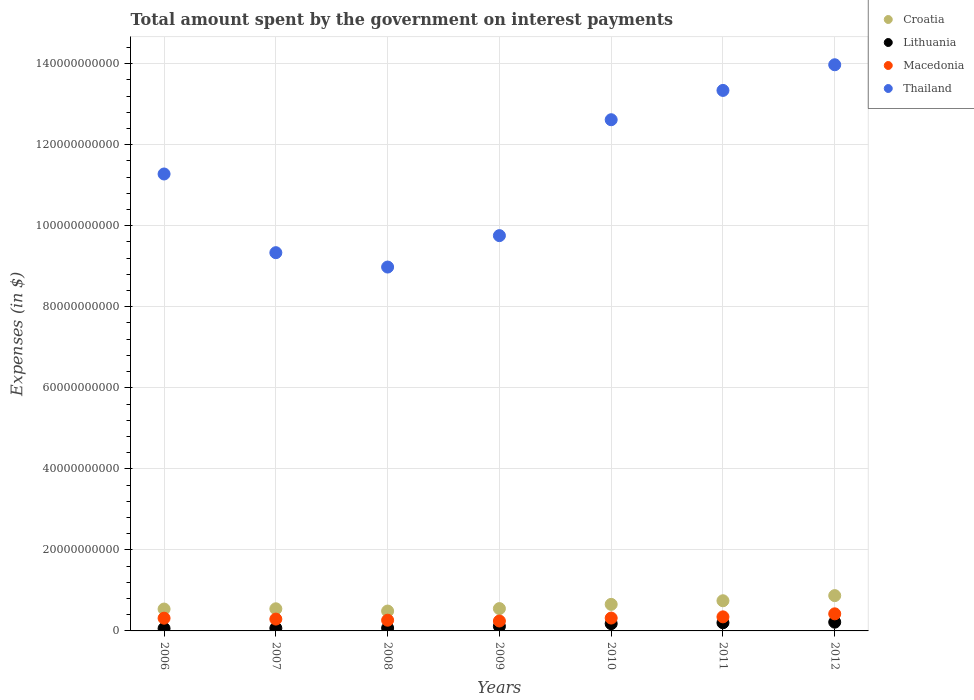How many different coloured dotlines are there?
Ensure brevity in your answer.  4. Is the number of dotlines equal to the number of legend labels?
Keep it short and to the point. Yes. What is the amount spent on interest payments by the government in Macedonia in 2010?
Provide a short and direct response. 3.17e+09. Across all years, what is the maximum amount spent on interest payments by the government in Thailand?
Offer a terse response. 1.40e+11. Across all years, what is the minimum amount spent on interest payments by the government in Macedonia?
Make the answer very short. 2.44e+09. In which year was the amount spent on interest payments by the government in Macedonia maximum?
Your response must be concise. 2012. What is the total amount spent on interest payments by the government in Thailand in the graph?
Make the answer very short. 7.93e+11. What is the difference between the amount spent on interest payments by the government in Croatia in 2007 and that in 2008?
Your response must be concise. 5.60e+08. What is the difference between the amount spent on interest payments by the government in Macedonia in 2012 and the amount spent on interest payments by the government in Lithuania in 2009?
Your response must be concise. 3.09e+09. What is the average amount spent on interest payments by the government in Thailand per year?
Give a very brief answer. 1.13e+11. In the year 2007, what is the difference between the amount spent on interest payments by the government in Croatia and amount spent on interest payments by the government in Thailand?
Provide a short and direct response. -8.79e+1. What is the ratio of the amount spent on interest payments by the government in Croatia in 2007 to that in 2011?
Your response must be concise. 0.73. Is the difference between the amount spent on interest payments by the government in Croatia in 2007 and 2008 greater than the difference between the amount spent on interest payments by the government in Thailand in 2007 and 2008?
Offer a very short reply. No. What is the difference between the highest and the second highest amount spent on interest payments by the government in Lithuania?
Make the answer very short. 1.48e+08. What is the difference between the highest and the lowest amount spent on interest payments by the government in Croatia?
Your response must be concise. 3.81e+09. In how many years, is the amount spent on interest payments by the government in Lithuania greater than the average amount spent on interest payments by the government in Lithuania taken over all years?
Keep it short and to the point. 3. Is the sum of the amount spent on interest payments by the government in Lithuania in 2008 and 2011 greater than the maximum amount spent on interest payments by the government in Macedonia across all years?
Your answer should be compact. No. Does the amount spent on interest payments by the government in Croatia monotonically increase over the years?
Offer a terse response. No. Is the amount spent on interest payments by the government in Macedonia strictly less than the amount spent on interest payments by the government in Lithuania over the years?
Your answer should be compact. No. What is the difference between two consecutive major ticks on the Y-axis?
Your answer should be very brief. 2.00e+1. Does the graph contain any zero values?
Ensure brevity in your answer.  No. Where does the legend appear in the graph?
Make the answer very short. Top right. How many legend labels are there?
Ensure brevity in your answer.  4. How are the legend labels stacked?
Your response must be concise. Vertical. What is the title of the graph?
Ensure brevity in your answer.  Total amount spent by the government on interest payments. What is the label or title of the Y-axis?
Offer a very short reply. Expenses (in $). What is the Expenses (in $) of Croatia in 2006?
Provide a succinct answer. 5.40e+09. What is the Expenses (in $) of Lithuania in 2006?
Offer a terse response. 6.00e+08. What is the Expenses (in $) in Macedonia in 2006?
Offer a very short reply. 3.14e+09. What is the Expenses (in $) in Thailand in 2006?
Make the answer very short. 1.13e+11. What is the Expenses (in $) of Croatia in 2007?
Keep it short and to the point. 5.46e+09. What is the Expenses (in $) of Lithuania in 2007?
Keep it short and to the point. 6.70e+08. What is the Expenses (in $) in Macedonia in 2007?
Your response must be concise. 2.92e+09. What is the Expenses (in $) in Thailand in 2007?
Offer a terse response. 9.33e+1. What is the Expenses (in $) in Croatia in 2008?
Provide a short and direct response. 4.90e+09. What is the Expenses (in $) in Lithuania in 2008?
Make the answer very short. 7.02e+08. What is the Expenses (in $) of Macedonia in 2008?
Provide a succinct answer. 2.65e+09. What is the Expenses (in $) in Thailand in 2008?
Your response must be concise. 8.98e+1. What is the Expenses (in $) in Croatia in 2009?
Offer a terse response. 5.51e+09. What is the Expenses (in $) in Lithuania in 2009?
Provide a succinct answer. 1.13e+09. What is the Expenses (in $) in Macedonia in 2009?
Your answer should be compact. 2.44e+09. What is the Expenses (in $) in Thailand in 2009?
Make the answer very short. 9.76e+1. What is the Expenses (in $) in Croatia in 2010?
Your response must be concise. 6.55e+09. What is the Expenses (in $) in Lithuania in 2010?
Give a very brief answer. 1.79e+09. What is the Expenses (in $) of Macedonia in 2010?
Provide a succinct answer. 3.17e+09. What is the Expenses (in $) in Thailand in 2010?
Your response must be concise. 1.26e+11. What is the Expenses (in $) in Croatia in 2011?
Keep it short and to the point. 7.44e+09. What is the Expenses (in $) of Lithuania in 2011?
Give a very brief answer. 2.01e+09. What is the Expenses (in $) of Macedonia in 2011?
Provide a succinct answer. 3.47e+09. What is the Expenses (in $) in Thailand in 2011?
Give a very brief answer. 1.33e+11. What is the Expenses (in $) in Croatia in 2012?
Provide a succinct answer. 8.71e+09. What is the Expenses (in $) of Lithuania in 2012?
Ensure brevity in your answer.  2.16e+09. What is the Expenses (in $) of Macedonia in 2012?
Offer a terse response. 4.22e+09. What is the Expenses (in $) of Thailand in 2012?
Provide a short and direct response. 1.40e+11. Across all years, what is the maximum Expenses (in $) of Croatia?
Offer a terse response. 8.71e+09. Across all years, what is the maximum Expenses (in $) of Lithuania?
Offer a terse response. 2.16e+09. Across all years, what is the maximum Expenses (in $) of Macedonia?
Offer a terse response. 4.22e+09. Across all years, what is the maximum Expenses (in $) in Thailand?
Ensure brevity in your answer.  1.40e+11. Across all years, what is the minimum Expenses (in $) in Croatia?
Provide a short and direct response. 4.90e+09. Across all years, what is the minimum Expenses (in $) in Lithuania?
Give a very brief answer. 6.00e+08. Across all years, what is the minimum Expenses (in $) of Macedonia?
Ensure brevity in your answer.  2.44e+09. Across all years, what is the minimum Expenses (in $) of Thailand?
Provide a succinct answer. 8.98e+1. What is the total Expenses (in $) in Croatia in the graph?
Your answer should be compact. 4.40e+1. What is the total Expenses (in $) of Lithuania in the graph?
Ensure brevity in your answer.  9.06e+09. What is the total Expenses (in $) of Macedonia in the graph?
Provide a short and direct response. 2.20e+1. What is the total Expenses (in $) of Thailand in the graph?
Your answer should be compact. 7.93e+11. What is the difference between the Expenses (in $) in Croatia in 2006 and that in 2007?
Your response must be concise. -6.40e+07. What is the difference between the Expenses (in $) in Lithuania in 2006 and that in 2007?
Make the answer very short. -7.02e+07. What is the difference between the Expenses (in $) of Macedonia in 2006 and that in 2007?
Provide a short and direct response. 2.22e+08. What is the difference between the Expenses (in $) of Thailand in 2006 and that in 2007?
Give a very brief answer. 1.94e+1. What is the difference between the Expenses (in $) in Croatia in 2006 and that in 2008?
Make the answer very short. 4.96e+08. What is the difference between the Expenses (in $) in Lithuania in 2006 and that in 2008?
Ensure brevity in your answer.  -1.02e+08. What is the difference between the Expenses (in $) in Macedonia in 2006 and that in 2008?
Give a very brief answer. 4.94e+08. What is the difference between the Expenses (in $) in Thailand in 2006 and that in 2008?
Offer a terse response. 2.30e+1. What is the difference between the Expenses (in $) in Croatia in 2006 and that in 2009?
Your response must be concise. -1.13e+08. What is the difference between the Expenses (in $) in Lithuania in 2006 and that in 2009?
Your response must be concise. -5.28e+08. What is the difference between the Expenses (in $) of Macedonia in 2006 and that in 2009?
Give a very brief answer. 6.95e+08. What is the difference between the Expenses (in $) in Thailand in 2006 and that in 2009?
Offer a very short reply. 1.52e+1. What is the difference between the Expenses (in $) in Croatia in 2006 and that in 2010?
Keep it short and to the point. -1.15e+09. What is the difference between the Expenses (in $) of Lithuania in 2006 and that in 2010?
Provide a short and direct response. -1.19e+09. What is the difference between the Expenses (in $) of Macedonia in 2006 and that in 2010?
Offer a very short reply. -3.39e+07. What is the difference between the Expenses (in $) of Thailand in 2006 and that in 2010?
Your response must be concise. -1.34e+1. What is the difference between the Expenses (in $) of Croatia in 2006 and that in 2011?
Offer a very short reply. -2.05e+09. What is the difference between the Expenses (in $) in Lithuania in 2006 and that in 2011?
Ensure brevity in your answer.  -1.41e+09. What is the difference between the Expenses (in $) in Macedonia in 2006 and that in 2011?
Provide a succinct answer. -3.31e+08. What is the difference between the Expenses (in $) of Thailand in 2006 and that in 2011?
Ensure brevity in your answer.  -2.06e+1. What is the difference between the Expenses (in $) in Croatia in 2006 and that in 2012?
Keep it short and to the point. -3.32e+09. What is the difference between the Expenses (in $) in Lithuania in 2006 and that in 2012?
Offer a terse response. -1.56e+09. What is the difference between the Expenses (in $) in Macedonia in 2006 and that in 2012?
Provide a succinct answer. -1.08e+09. What is the difference between the Expenses (in $) in Thailand in 2006 and that in 2012?
Provide a succinct answer. -2.70e+1. What is the difference between the Expenses (in $) in Croatia in 2007 and that in 2008?
Your response must be concise. 5.60e+08. What is the difference between the Expenses (in $) in Lithuania in 2007 and that in 2008?
Offer a terse response. -3.16e+07. What is the difference between the Expenses (in $) in Macedonia in 2007 and that in 2008?
Provide a succinct answer. 2.72e+08. What is the difference between the Expenses (in $) of Thailand in 2007 and that in 2008?
Offer a very short reply. 3.55e+09. What is the difference between the Expenses (in $) in Croatia in 2007 and that in 2009?
Provide a short and direct response. -4.88e+07. What is the difference between the Expenses (in $) in Lithuania in 2007 and that in 2009?
Provide a succinct answer. -4.57e+08. What is the difference between the Expenses (in $) of Macedonia in 2007 and that in 2009?
Your response must be concise. 4.73e+08. What is the difference between the Expenses (in $) in Thailand in 2007 and that in 2009?
Make the answer very short. -4.21e+09. What is the difference between the Expenses (in $) in Croatia in 2007 and that in 2010?
Keep it short and to the point. -1.09e+09. What is the difference between the Expenses (in $) of Lithuania in 2007 and that in 2010?
Provide a succinct answer. -1.12e+09. What is the difference between the Expenses (in $) of Macedonia in 2007 and that in 2010?
Provide a short and direct response. -2.56e+08. What is the difference between the Expenses (in $) in Thailand in 2007 and that in 2010?
Your answer should be very brief. -3.28e+1. What is the difference between the Expenses (in $) in Croatia in 2007 and that in 2011?
Give a very brief answer. -1.98e+09. What is the difference between the Expenses (in $) of Lithuania in 2007 and that in 2011?
Give a very brief answer. -1.34e+09. What is the difference between the Expenses (in $) of Macedonia in 2007 and that in 2011?
Keep it short and to the point. -5.53e+08. What is the difference between the Expenses (in $) of Thailand in 2007 and that in 2011?
Offer a terse response. -4.00e+1. What is the difference between the Expenses (in $) of Croatia in 2007 and that in 2012?
Give a very brief answer. -3.25e+09. What is the difference between the Expenses (in $) of Lithuania in 2007 and that in 2012?
Offer a terse response. -1.49e+09. What is the difference between the Expenses (in $) in Macedonia in 2007 and that in 2012?
Make the answer very short. -1.30e+09. What is the difference between the Expenses (in $) of Thailand in 2007 and that in 2012?
Your response must be concise. -4.64e+1. What is the difference between the Expenses (in $) in Croatia in 2008 and that in 2009?
Give a very brief answer. -6.09e+08. What is the difference between the Expenses (in $) of Lithuania in 2008 and that in 2009?
Ensure brevity in your answer.  -4.26e+08. What is the difference between the Expenses (in $) in Macedonia in 2008 and that in 2009?
Provide a short and direct response. 2.01e+08. What is the difference between the Expenses (in $) in Thailand in 2008 and that in 2009?
Your response must be concise. -7.75e+09. What is the difference between the Expenses (in $) of Croatia in 2008 and that in 2010?
Keep it short and to the point. -1.65e+09. What is the difference between the Expenses (in $) in Lithuania in 2008 and that in 2010?
Ensure brevity in your answer.  -1.09e+09. What is the difference between the Expenses (in $) in Macedonia in 2008 and that in 2010?
Your answer should be compact. -5.28e+08. What is the difference between the Expenses (in $) in Thailand in 2008 and that in 2010?
Provide a succinct answer. -3.64e+1. What is the difference between the Expenses (in $) in Croatia in 2008 and that in 2011?
Offer a very short reply. -2.54e+09. What is the difference between the Expenses (in $) in Lithuania in 2008 and that in 2011?
Provide a short and direct response. -1.31e+09. What is the difference between the Expenses (in $) in Macedonia in 2008 and that in 2011?
Make the answer very short. -8.25e+08. What is the difference between the Expenses (in $) of Thailand in 2008 and that in 2011?
Your response must be concise. -4.36e+1. What is the difference between the Expenses (in $) in Croatia in 2008 and that in 2012?
Keep it short and to the point. -3.81e+09. What is the difference between the Expenses (in $) of Lithuania in 2008 and that in 2012?
Offer a terse response. -1.46e+09. What is the difference between the Expenses (in $) of Macedonia in 2008 and that in 2012?
Provide a succinct answer. -1.57e+09. What is the difference between the Expenses (in $) of Thailand in 2008 and that in 2012?
Provide a short and direct response. -4.99e+1. What is the difference between the Expenses (in $) of Croatia in 2009 and that in 2010?
Provide a succinct answer. -1.04e+09. What is the difference between the Expenses (in $) in Lithuania in 2009 and that in 2010?
Offer a very short reply. -6.61e+08. What is the difference between the Expenses (in $) of Macedonia in 2009 and that in 2010?
Give a very brief answer. -7.29e+08. What is the difference between the Expenses (in $) of Thailand in 2009 and that in 2010?
Make the answer very short. -2.86e+1. What is the difference between the Expenses (in $) in Croatia in 2009 and that in 2011?
Make the answer very short. -1.93e+09. What is the difference between the Expenses (in $) in Lithuania in 2009 and that in 2011?
Provide a succinct answer. -8.82e+08. What is the difference between the Expenses (in $) of Macedonia in 2009 and that in 2011?
Give a very brief answer. -1.03e+09. What is the difference between the Expenses (in $) in Thailand in 2009 and that in 2011?
Give a very brief answer. -3.58e+1. What is the difference between the Expenses (in $) in Croatia in 2009 and that in 2012?
Your response must be concise. -3.20e+09. What is the difference between the Expenses (in $) in Lithuania in 2009 and that in 2012?
Your answer should be compact. -1.03e+09. What is the difference between the Expenses (in $) in Macedonia in 2009 and that in 2012?
Offer a very short reply. -1.77e+09. What is the difference between the Expenses (in $) of Thailand in 2009 and that in 2012?
Your response must be concise. -4.22e+1. What is the difference between the Expenses (in $) in Croatia in 2010 and that in 2011?
Provide a succinct answer. -8.93e+08. What is the difference between the Expenses (in $) in Lithuania in 2010 and that in 2011?
Your answer should be very brief. -2.20e+08. What is the difference between the Expenses (in $) in Macedonia in 2010 and that in 2011?
Ensure brevity in your answer.  -2.97e+08. What is the difference between the Expenses (in $) in Thailand in 2010 and that in 2011?
Provide a succinct answer. -7.23e+09. What is the difference between the Expenses (in $) in Croatia in 2010 and that in 2012?
Your response must be concise. -2.16e+09. What is the difference between the Expenses (in $) in Lithuania in 2010 and that in 2012?
Offer a terse response. -3.69e+08. What is the difference between the Expenses (in $) of Macedonia in 2010 and that in 2012?
Offer a terse response. -1.04e+09. What is the difference between the Expenses (in $) of Thailand in 2010 and that in 2012?
Your response must be concise. -1.36e+1. What is the difference between the Expenses (in $) of Croatia in 2011 and that in 2012?
Provide a short and direct response. -1.27e+09. What is the difference between the Expenses (in $) of Lithuania in 2011 and that in 2012?
Give a very brief answer. -1.48e+08. What is the difference between the Expenses (in $) in Macedonia in 2011 and that in 2012?
Ensure brevity in your answer.  -7.45e+08. What is the difference between the Expenses (in $) in Thailand in 2011 and that in 2012?
Offer a terse response. -6.33e+09. What is the difference between the Expenses (in $) in Croatia in 2006 and the Expenses (in $) in Lithuania in 2007?
Your response must be concise. 4.73e+09. What is the difference between the Expenses (in $) in Croatia in 2006 and the Expenses (in $) in Macedonia in 2007?
Provide a succinct answer. 2.48e+09. What is the difference between the Expenses (in $) of Croatia in 2006 and the Expenses (in $) of Thailand in 2007?
Offer a very short reply. -8.80e+1. What is the difference between the Expenses (in $) in Lithuania in 2006 and the Expenses (in $) in Macedonia in 2007?
Provide a short and direct response. -2.32e+09. What is the difference between the Expenses (in $) of Lithuania in 2006 and the Expenses (in $) of Thailand in 2007?
Ensure brevity in your answer.  -9.27e+1. What is the difference between the Expenses (in $) of Macedonia in 2006 and the Expenses (in $) of Thailand in 2007?
Your answer should be compact. -9.02e+1. What is the difference between the Expenses (in $) of Croatia in 2006 and the Expenses (in $) of Lithuania in 2008?
Your response must be concise. 4.69e+09. What is the difference between the Expenses (in $) of Croatia in 2006 and the Expenses (in $) of Macedonia in 2008?
Your answer should be very brief. 2.75e+09. What is the difference between the Expenses (in $) in Croatia in 2006 and the Expenses (in $) in Thailand in 2008?
Provide a succinct answer. -8.44e+1. What is the difference between the Expenses (in $) of Lithuania in 2006 and the Expenses (in $) of Macedonia in 2008?
Offer a terse response. -2.05e+09. What is the difference between the Expenses (in $) in Lithuania in 2006 and the Expenses (in $) in Thailand in 2008?
Make the answer very short. -8.92e+1. What is the difference between the Expenses (in $) of Macedonia in 2006 and the Expenses (in $) of Thailand in 2008?
Provide a short and direct response. -8.67e+1. What is the difference between the Expenses (in $) of Croatia in 2006 and the Expenses (in $) of Lithuania in 2009?
Give a very brief answer. 4.27e+09. What is the difference between the Expenses (in $) of Croatia in 2006 and the Expenses (in $) of Macedonia in 2009?
Provide a succinct answer. 2.95e+09. What is the difference between the Expenses (in $) in Croatia in 2006 and the Expenses (in $) in Thailand in 2009?
Provide a short and direct response. -9.22e+1. What is the difference between the Expenses (in $) in Lithuania in 2006 and the Expenses (in $) in Macedonia in 2009?
Give a very brief answer. -1.84e+09. What is the difference between the Expenses (in $) in Lithuania in 2006 and the Expenses (in $) in Thailand in 2009?
Provide a succinct answer. -9.70e+1. What is the difference between the Expenses (in $) of Macedonia in 2006 and the Expenses (in $) of Thailand in 2009?
Offer a terse response. -9.44e+1. What is the difference between the Expenses (in $) in Croatia in 2006 and the Expenses (in $) in Lithuania in 2010?
Your response must be concise. 3.61e+09. What is the difference between the Expenses (in $) of Croatia in 2006 and the Expenses (in $) of Macedonia in 2010?
Your response must be concise. 2.22e+09. What is the difference between the Expenses (in $) in Croatia in 2006 and the Expenses (in $) in Thailand in 2010?
Provide a short and direct response. -1.21e+11. What is the difference between the Expenses (in $) in Lithuania in 2006 and the Expenses (in $) in Macedonia in 2010?
Offer a very short reply. -2.57e+09. What is the difference between the Expenses (in $) of Lithuania in 2006 and the Expenses (in $) of Thailand in 2010?
Offer a terse response. -1.26e+11. What is the difference between the Expenses (in $) of Macedonia in 2006 and the Expenses (in $) of Thailand in 2010?
Your answer should be compact. -1.23e+11. What is the difference between the Expenses (in $) in Croatia in 2006 and the Expenses (in $) in Lithuania in 2011?
Provide a short and direct response. 3.39e+09. What is the difference between the Expenses (in $) in Croatia in 2006 and the Expenses (in $) in Macedonia in 2011?
Provide a succinct answer. 1.93e+09. What is the difference between the Expenses (in $) of Croatia in 2006 and the Expenses (in $) of Thailand in 2011?
Offer a very short reply. -1.28e+11. What is the difference between the Expenses (in $) in Lithuania in 2006 and the Expenses (in $) in Macedonia in 2011?
Your response must be concise. -2.87e+09. What is the difference between the Expenses (in $) of Lithuania in 2006 and the Expenses (in $) of Thailand in 2011?
Provide a short and direct response. -1.33e+11. What is the difference between the Expenses (in $) in Macedonia in 2006 and the Expenses (in $) in Thailand in 2011?
Ensure brevity in your answer.  -1.30e+11. What is the difference between the Expenses (in $) of Croatia in 2006 and the Expenses (in $) of Lithuania in 2012?
Make the answer very short. 3.24e+09. What is the difference between the Expenses (in $) in Croatia in 2006 and the Expenses (in $) in Macedonia in 2012?
Your answer should be very brief. 1.18e+09. What is the difference between the Expenses (in $) in Croatia in 2006 and the Expenses (in $) in Thailand in 2012?
Make the answer very short. -1.34e+11. What is the difference between the Expenses (in $) in Lithuania in 2006 and the Expenses (in $) in Macedonia in 2012?
Offer a very short reply. -3.62e+09. What is the difference between the Expenses (in $) in Lithuania in 2006 and the Expenses (in $) in Thailand in 2012?
Your answer should be very brief. -1.39e+11. What is the difference between the Expenses (in $) in Macedonia in 2006 and the Expenses (in $) in Thailand in 2012?
Offer a terse response. -1.37e+11. What is the difference between the Expenses (in $) of Croatia in 2007 and the Expenses (in $) of Lithuania in 2008?
Your answer should be very brief. 4.76e+09. What is the difference between the Expenses (in $) of Croatia in 2007 and the Expenses (in $) of Macedonia in 2008?
Your response must be concise. 2.82e+09. What is the difference between the Expenses (in $) in Croatia in 2007 and the Expenses (in $) in Thailand in 2008?
Your answer should be compact. -8.43e+1. What is the difference between the Expenses (in $) of Lithuania in 2007 and the Expenses (in $) of Macedonia in 2008?
Your answer should be compact. -1.98e+09. What is the difference between the Expenses (in $) in Lithuania in 2007 and the Expenses (in $) in Thailand in 2008?
Your answer should be very brief. -8.91e+1. What is the difference between the Expenses (in $) of Macedonia in 2007 and the Expenses (in $) of Thailand in 2008?
Give a very brief answer. -8.69e+1. What is the difference between the Expenses (in $) in Croatia in 2007 and the Expenses (in $) in Lithuania in 2009?
Keep it short and to the point. 4.33e+09. What is the difference between the Expenses (in $) of Croatia in 2007 and the Expenses (in $) of Macedonia in 2009?
Keep it short and to the point. 3.02e+09. What is the difference between the Expenses (in $) in Croatia in 2007 and the Expenses (in $) in Thailand in 2009?
Your answer should be very brief. -9.21e+1. What is the difference between the Expenses (in $) in Lithuania in 2007 and the Expenses (in $) in Macedonia in 2009?
Keep it short and to the point. -1.77e+09. What is the difference between the Expenses (in $) of Lithuania in 2007 and the Expenses (in $) of Thailand in 2009?
Provide a succinct answer. -9.69e+1. What is the difference between the Expenses (in $) of Macedonia in 2007 and the Expenses (in $) of Thailand in 2009?
Keep it short and to the point. -9.46e+1. What is the difference between the Expenses (in $) of Croatia in 2007 and the Expenses (in $) of Lithuania in 2010?
Keep it short and to the point. 3.67e+09. What is the difference between the Expenses (in $) in Croatia in 2007 and the Expenses (in $) in Macedonia in 2010?
Your response must be concise. 2.29e+09. What is the difference between the Expenses (in $) of Croatia in 2007 and the Expenses (in $) of Thailand in 2010?
Provide a short and direct response. -1.21e+11. What is the difference between the Expenses (in $) in Lithuania in 2007 and the Expenses (in $) in Macedonia in 2010?
Offer a terse response. -2.50e+09. What is the difference between the Expenses (in $) of Lithuania in 2007 and the Expenses (in $) of Thailand in 2010?
Ensure brevity in your answer.  -1.25e+11. What is the difference between the Expenses (in $) in Macedonia in 2007 and the Expenses (in $) in Thailand in 2010?
Your response must be concise. -1.23e+11. What is the difference between the Expenses (in $) in Croatia in 2007 and the Expenses (in $) in Lithuania in 2011?
Keep it short and to the point. 3.45e+09. What is the difference between the Expenses (in $) of Croatia in 2007 and the Expenses (in $) of Macedonia in 2011?
Your answer should be very brief. 1.99e+09. What is the difference between the Expenses (in $) in Croatia in 2007 and the Expenses (in $) in Thailand in 2011?
Provide a succinct answer. -1.28e+11. What is the difference between the Expenses (in $) in Lithuania in 2007 and the Expenses (in $) in Macedonia in 2011?
Your response must be concise. -2.80e+09. What is the difference between the Expenses (in $) in Lithuania in 2007 and the Expenses (in $) in Thailand in 2011?
Keep it short and to the point. -1.33e+11. What is the difference between the Expenses (in $) of Macedonia in 2007 and the Expenses (in $) of Thailand in 2011?
Your answer should be very brief. -1.30e+11. What is the difference between the Expenses (in $) of Croatia in 2007 and the Expenses (in $) of Lithuania in 2012?
Make the answer very short. 3.30e+09. What is the difference between the Expenses (in $) in Croatia in 2007 and the Expenses (in $) in Macedonia in 2012?
Offer a very short reply. 1.24e+09. What is the difference between the Expenses (in $) of Croatia in 2007 and the Expenses (in $) of Thailand in 2012?
Ensure brevity in your answer.  -1.34e+11. What is the difference between the Expenses (in $) in Lithuania in 2007 and the Expenses (in $) in Macedonia in 2012?
Your response must be concise. -3.55e+09. What is the difference between the Expenses (in $) in Lithuania in 2007 and the Expenses (in $) in Thailand in 2012?
Make the answer very short. -1.39e+11. What is the difference between the Expenses (in $) in Macedonia in 2007 and the Expenses (in $) in Thailand in 2012?
Your response must be concise. -1.37e+11. What is the difference between the Expenses (in $) in Croatia in 2008 and the Expenses (in $) in Lithuania in 2009?
Your answer should be very brief. 3.77e+09. What is the difference between the Expenses (in $) in Croatia in 2008 and the Expenses (in $) in Macedonia in 2009?
Ensure brevity in your answer.  2.46e+09. What is the difference between the Expenses (in $) of Croatia in 2008 and the Expenses (in $) of Thailand in 2009?
Provide a short and direct response. -9.27e+1. What is the difference between the Expenses (in $) of Lithuania in 2008 and the Expenses (in $) of Macedonia in 2009?
Provide a short and direct response. -1.74e+09. What is the difference between the Expenses (in $) in Lithuania in 2008 and the Expenses (in $) in Thailand in 2009?
Ensure brevity in your answer.  -9.69e+1. What is the difference between the Expenses (in $) of Macedonia in 2008 and the Expenses (in $) of Thailand in 2009?
Offer a very short reply. -9.49e+1. What is the difference between the Expenses (in $) of Croatia in 2008 and the Expenses (in $) of Lithuania in 2010?
Provide a short and direct response. 3.11e+09. What is the difference between the Expenses (in $) in Croatia in 2008 and the Expenses (in $) in Macedonia in 2010?
Your answer should be very brief. 1.73e+09. What is the difference between the Expenses (in $) of Croatia in 2008 and the Expenses (in $) of Thailand in 2010?
Give a very brief answer. -1.21e+11. What is the difference between the Expenses (in $) in Lithuania in 2008 and the Expenses (in $) in Macedonia in 2010?
Give a very brief answer. -2.47e+09. What is the difference between the Expenses (in $) of Lithuania in 2008 and the Expenses (in $) of Thailand in 2010?
Give a very brief answer. -1.25e+11. What is the difference between the Expenses (in $) of Macedonia in 2008 and the Expenses (in $) of Thailand in 2010?
Offer a very short reply. -1.24e+11. What is the difference between the Expenses (in $) of Croatia in 2008 and the Expenses (in $) of Lithuania in 2011?
Provide a short and direct response. 2.89e+09. What is the difference between the Expenses (in $) of Croatia in 2008 and the Expenses (in $) of Macedonia in 2011?
Your answer should be very brief. 1.43e+09. What is the difference between the Expenses (in $) in Croatia in 2008 and the Expenses (in $) in Thailand in 2011?
Offer a very short reply. -1.28e+11. What is the difference between the Expenses (in $) in Lithuania in 2008 and the Expenses (in $) in Macedonia in 2011?
Provide a succinct answer. -2.77e+09. What is the difference between the Expenses (in $) of Lithuania in 2008 and the Expenses (in $) of Thailand in 2011?
Provide a short and direct response. -1.33e+11. What is the difference between the Expenses (in $) in Macedonia in 2008 and the Expenses (in $) in Thailand in 2011?
Offer a very short reply. -1.31e+11. What is the difference between the Expenses (in $) of Croatia in 2008 and the Expenses (in $) of Lithuania in 2012?
Your answer should be very brief. 2.74e+09. What is the difference between the Expenses (in $) of Croatia in 2008 and the Expenses (in $) of Macedonia in 2012?
Give a very brief answer. 6.85e+08. What is the difference between the Expenses (in $) in Croatia in 2008 and the Expenses (in $) in Thailand in 2012?
Give a very brief answer. -1.35e+11. What is the difference between the Expenses (in $) in Lithuania in 2008 and the Expenses (in $) in Macedonia in 2012?
Make the answer very short. -3.51e+09. What is the difference between the Expenses (in $) of Lithuania in 2008 and the Expenses (in $) of Thailand in 2012?
Provide a short and direct response. -1.39e+11. What is the difference between the Expenses (in $) in Macedonia in 2008 and the Expenses (in $) in Thailand in 2012?
Provide a succinct answer. -1.37e+11. What is the difference between the Expenses (in $) of Croatia in 2009 and the Expenses (in $) of Lithuania in 2010?
Your response must be concise. 3.72e+09. What is the difference between the Expenses (in $) of Croatia in 2009 and the Expenses (in $) of Macedonia in 2010?
Ensure brevity in your answer.  2.34e+09. What is the difference between the Expenses (in $) in Croatia in 2009 and the Expenses (in $) in Thailand in 2010?
Provide a short and direct response. -1.21e+11. What is the difference between the Expenses (in $) of Lithuania in 2009 and the Expenses (in $) of Macedonia in 2010?
Provide a short and direct response. -2.05e+09. What is the difference between the Expenses (in $) in Lithuania in 2009 and the Expenses (in $) in Thailand in 2010?
Provide a succinct answer. -1.25e+11. What is the difference between the Expenses (in $) in Macedonia in 2009 and the Expenses (in $) in Thailand in 2010?
Your answer should be very brief. -1.24e+11. What is the difference between the Expenses (in $) in Croatia in 2009 and the Expenses (in $) in Lithuania in 2011?
Provide a succinct answer. 3.50e+09. What is the difference between the Expenses (in $) in Croatia in 2009 and the Expenses (in $) in Macedonia in 2011?
Give a very brief answer. 2.04e+09. What is the difference between the Expenses (in $) in Croatia in 2009 and the Expenses (in $) in Thailand in 2011?
Provide a short and direct response. -1.28e+11. What is the difference between the Expenses (in $) in Lithuania in 2009 and the Expenses (in $) in Macedonia in 2011?
Ensure brevity in your answer.  -2.34e+09. What is the difference between the Expenses (in $) of Lithuania in 2009 and the Expenses (in $) of Thailand in 2011?
Ensure brevity in your answer.  -1.32e+11. What is the difference between the Expenses (in $) of Macedonia in 2009 and the Expenses (in $) of Thailand in 2011?
Offer a terse response. -1.31e+11. What is the difference between the Expenses (in $) in Croatia in 2009 and the Expenses (in $) in Lithuania in 2012?
Your response must be concise. 3.35e+09. What is the difference between the Expenses (in $) of Croatia in 2009 and the Expenses (in $) of Macedonia in 2012?
Offer a terse response. 1.29e+09. What is the difference between the Expenses (in $) in Croatia in 2009 and the Expenses (in $) in Thailand in 2012?
Offer a terse response. -1.34e+11. What is the difference between the Expenses (in $) of Lithuania in 2009 and the Expenses (in $) of Macedonia in 2012?
Your response must be concise. -3.09e+09. What is the difference between the Expenses (in $) of Lithuania in 2009 and the Expenses (in $) of Thailand in 2012?
Ensure brevity in your answer.  -1.39e+11. What is the difference between the Expenses (in $) of Macedonia in 2009 and the Expenses (in $) of Thailand in 2012?
Provide a succinct answer. -1.37e+11. What is the difference between the Expenses (in $) in Croatia in 2010 and the Expenses (in $) in Lithuania in 2011?
Provide a succinct answer. 4.54e+09. What is the difference between the Expenses (in $) of Croatia in 2010 and the Expenses (in $) of Macedonia in 2011?
Provide a short and direct response. 3.08e+09. What is the difference between the Expenses (in $) in Croatia in 2010 and the Expenses (in $) in Thailand in 2011?
Offer a terse response. -1.27e+11. What is the difference between the Expenses (in $) in Lithuania in 2010 and the Expenses (in $) in Macedonia in 2011?
Provide a succinct answer. -1.68e+09. What is the difference between the Expenses (in $) in Lithuania in 2010 and the Expenses (in $) in Thailand in 2011?
Your response must be concise. -1.32e+11. What is the difference between the Expenses (in $) of Macedonia in 2010 and the Expenses (in $) of Thailand in 2011?
Provide a succinct answer. -1.30e+11. What is the difference between the Expenses (in $) in Croatia in 2010 and the Expenses (in $) in Lithuania in 2012?
Your answer should be very brief. 4.39e+09. What is the difference between the Expenses (in $) of Croatia in 2010 and the Expenses (in $) of Macedonia in 2012?
Provide a short and direct response. 2.34e+09. What is the difference between the Expenses (in $) in Croatia in 2010 and the Expenses (in $) in Thailand in 2012?
Your response must be concise. -1.33e+11. What is the difference between the Expenses (in $) of Lithuania in 2010 and the Expenses (in $) of Macedonia in 2012?
Offer a very short reply. -2.43e+09. What is the difference between the Expenses (in $) in Lithuania in 2010 and the Expenses (in $) in Thailand in 2012?
Keep it short and to the point. -1.38e+11. What is the difference between the Expenses (in $) in Macedonia in 2010 and the Expenses (in $) in Thailand in 2012?
Give a very brief answer. -1.37e+11. What is the difference between the Expenses (in $) of Croatia in 2011 and the Expenses (in $) of Lithuania in 2012?
Keep it short and to the point. 5.29e+09. What is the difference between the Expenses (in $) in Croatia in 2011 and the Expenses (in $) in Macedonia in 2012?
Keep it short and to the point. 3.23e+09. What is the difference between the Expenses (in $) of Croatia in 2011 and the Expenses (in $) of Thailand in 2012?
Offer a very short reply. -1.32e+11. What is the difference between the Expenses (in $) of Lithuania in 2011 and the Expenses (in $) of Macedonia in 2012?
Ensure brevity in your answer.  -2.21e+09. What is the difference between the Expenses (in $) in Lithuania in 2011 and the Expenses (in $) in Thailand in 2012?
Make the answer very short. -1.38e+11. What is the difference between the Expenses (in $) in Macedonia in 2011 and the Expenses (in $) in Thailand in 2012?
Your response must be concise. -1.36e+11. What is the average Expenses (in $) of Croatia per year?
Provide a short and direct response. 6.28e+09. What is the average Expenses (in $) of Lithuania per year?
Your answer should be compact. 1.29e+09. What is the average Expenses (in $) in Macedonia per year?
Give a very brief answer. 3.14e+09. What is the average Expenses (in $) in Thailand per year?
Ensure brevity in your answer.  1.13e+11. In the year 2006, what is the difference between the Expenses (in $) of Croatia and Expenses (in $) of Lithuania?
Keep it short and to the point. 4.80e+09. In the year 2006, what is the difference between the Expenses (in $) of Croatia and Expenses (in $) of Macedonia?
Offer a terse response. 2.26e+09. In the year 2006, what is the difference between the Expenses (in $) of Croatia and Expenses (in $) of Thailand?
Ensure brevity in your answer.  -1.07e+11. In the year 2006, what is the difference between the Expenses (in $) in Lithuania and Expenses (in $) in Macedonia?
Provide a succinct answer. -2.54e+09. In the year 2006, what is the difference between the Expenses (in $) in Lithuania and Expenses (in $) in Thailand?
Offer a terse response. -1.12e+11. In the year 2006, what is the difference between the Expenses (in $) of Macedonia and Expenses (in $) of Thailand?
Make the answer very short. -1.10e+11. In the year 2007, what is the difference between the Expenses (in $) in Croatia and Expenses (in $) in Lithuania?
Provide a short and direct response. 4.79e+09. In the year 2007, what is the difference between the Expenses (in $) of Croatia and Expenses (in $) of Macedonia?
Offer a very short reply. 2.54e+09. In the year 2007, what is the difference between the Expenses (in $) of Croatia and Expenses (in $) of Thailand?
Make the answer very short. -8.79e+1. In the year 2007, what is the difference between the Expenses (in $) in Lithuania and Expenses (in $) in Macedonia?
Give a very brief answer. -2.25e+09. In the year 2007, what is the difference between the Expenses (in $) in Lithuania and Expenses (in $) in Thailand?
Your answer should be compact. -9.27e+1. In the year 2007, what is the difference between the Expenses (in $) of Macedonia and Expenses (in $) of Thailand?
Make the answer very short. -9.04e+1. In the year 2008, what is the difference between the Expenses (in $) of Croatia and Expenses (in $) of Lithuania?
Offer a very short reply. 4.20e+09. In the year 2008, what is the difference between the Expenses (in $) of Croatia and Expenses (in $) of Macedonia?
Provide a succinct answer. 2.26e+09. In the year 2008, what is the difference between the Expenses (in $) in Croatia and Expenses (in $) in Thailand?
Provide a short and direct response. -8.49e+1. In the year 2008, what is the difference between the Expenses (in $) in Lithuania and Expenses (in $) in Macedonia?
Make the answer very short. -1.94e+09. In the year 2008, what is the difference between the Expenses (in $) of Lithuania and Expenses (in $) of Thailand?
Provide a short and direct response. -8.91e+1. In the year 2008, what is the difference between the Expenses (in $) in Macedonia and Expenses (in $) in Thailand?
Keep it short and to the point. -8.72e+1. In the year 2009, what is the difference between the Expenses (in $) in Croatia and Expenses (in $) in Lithuania?
Provide a short and direct response. 4.38e+09. In the year 2009, what is the difference between the Expenses (in $) of Croatia and Expenses (in $) of Macedonia?
Offer a very short reply. 3.06e+09. In the year 2009, what is the difference between the Expenses (in $) in Croatia and Expenses (in $) in Thailand?
Keep it short and to the point. -9.20e+1. In the year 2009, what is the difference between the Expenses (in $) in Lithuania and Expenses (in $) in Macedonia?
Ensure brevity in your answer.  -1.32e+09. In the year 2009, what is the difference between the Expenses (in $) in Lithuania and Expenses (in $) in Thailand?
Offer a very short reply. -9.64e+1. In the year 2009, what is the difference between the Expenses (in $) of Macedonia and Expenses (in $) of Thailand?
Keep it short and to the point. -9.51e+1. In the year 2010, what is the difference between the Expenses (in $) of Croatia and Expenses (in $) of Lithuania?
Give a very brief answer. 4.76e+09. In the year 2010, what is the difference between the Expenses (in $) in Croatia and Expenses (in $) in Macedonia?
Ensure brevity in your answer.  3.38e+09. In the year 2010, what is the difference between the Expenses (in $) of Croatia and Expenses (in $) of Thailand?
Give a very brief answer. -1.20e+11. In the year 2010, what is the difference between the Expenses (in $) in Lithuania and Expenses (in $) in Macedonia?
Make the answer very short. -1.38e+09. In the year 2010, what is the difference between the Expenses (in $) of Lithuania and Expenses (in $) of Thailand?
Your response must be concise. -1.24e+11. In the year 2010, what is the difference between the Expenses (in $) in Macedonia and Expenses (in $) in Thailand?
Offer a very short reply. -1.23e+11. In the year 2011, what is the difference between the Expenses (in $) of Croatia and Expenses (in $) of Lithuania?
Give a very brief answer. 5.44e+09. In the year 2011, what is the difference between the Expenses (in $) in Croatia and Expenses (in $) in Macedonia?
Give a very brief answer. 3.97e+09. In the year 2011, what is the difference between the Expenses (in $) of Croatia and Expenses (in $) of Thailand?
Your answer should be compact. -1.26e+11. In the year 2011, what is the difference between the Expenses (in $) in Lithuania and Expenses (in $) in Macedonia?
Provide a succinct answer. -1.46e+09. In the year 2011, what is the difference between the Expenses (in $) of Lithuania and Expenses (in $) of Thailand?
Ensure brevity in your answer.  -1.31e+11. In the year 2011, what is the difference between the Expenses (in $) in Macedonia and Expenses (in $) in Thailand?
Make the answer very short. -1.30e+11. In the year 2012, what is the difference between the Expenses (in $) in Croatia and Expenses (in $) in Lithuania?
Your answer should be very brief. 6.56e+09. In the year 2012, what is the difference between the Expenses (in $) of Croatia and Expenses (in $) of Macedonia?
Provide a succinct answer. 4.50e+09. In the year 2012, what is the difference between the Expenses (in $) in Croatia and Expenses (in $) in Thailand?
Keep it short and to the point. -1.31e+11. In the year 2012, what is the difference between the Expenses (in $) in Lithuania and Expenses (in $) in Macedonia?
Provide a short and direct response. -2.06e+09. In the year 2012, what is the difference between the Expenses (in $) in Lithuania and Expenses (in $) in Thailand?
Ensure brevity in your answer.  -1.38e+11. In the year 2012, what is the difference between the Expenses (in $) of Macedonia and Expenses (in $) of Thailand?
Provide a short and direct response. -1.36e+11. What is the ratio of the Expenses (in $) in Croatia in 2006 to that in 2007?
Offer a terse response. 0.99. What is the ratio of the Expenses (in $) in Lithuania in 2006 to that in 2007?
Offer a very short reply. 0.9. What is the ratio of the Expenses (in $) of Macedonia in 2006 to that in 2007?
Ensure brevity in your answer.  1.08. What is the ratio of the Expenses (in $) in Thailand in 2006 to that in 2007?
Offer a very short reply. 1.21. What is the ratio of the Expenses (in $) of Croatia in 2006 to that in 2008?
Give a very brief answer. 1.1. What is the ratio of the Expenses (in $) of Lithuania in 2006 to that in 2008?
Provide a short and direct response. 0.85. What is the ratio of the Expenses (in $) of Macedonia in 2006 to that in 2008?
Offer a terse response. 1.19. What is the ratio of the Expenses (in $) of Thailand in 2006 to that in 2008?
Offer a very short reply. 1.26. What is the ratio of the Expenses (in $) in Croatia in 2006 to that in 2009?
Your response must be concise. 0.98. What is the ratio of the Expenses (in $) of Lithuania in 2006 to that in 2009?
Provide a short and direct response. 0.53. What is the ratio of the Expenses (in $) in Macedonia in 2006 to that in 2009?
Your response must be concise. 1.28. What is the ratio of the Expenses (in $) in Thailand in 2006 to that in 2009?
Keep it short and to the point. 1.16. What is the ratio of the Expenses (in $) in Croatia in 2006 to that in 2010?
Your answer should be compact. 0.82. What is the ratio of the Expenses (in $) of Lithuania in 2006 to that in 2010?
Your answer should be compact. 0.34. What is the ratio of the Expenses (in $) of Macedonia in 2006 to that in 2010?
Keep it short and to the point. 0.99. What is the ratio of the Expenses (in $) in Thailand in 2006 to that in 2010?
Give a very brief answer. 0.89. What is the ratio of the Expenses (in $) of Croatia in 2006 to that in 2011?
Give a very brief answer. 0.72. What is the ratio of the Expenses (in $) of Lithuania in 2006 to that in 2011?
Your answer should be very brief. 0.3. What is the ratio of the Expenses (in $) of Macedonia in 2006 to that in 2011?
Your answer should be compact. 0.9. What is the ratio of the Expenses (in $) in Thailand in 2006 to that in 2011?
Make the answer very short. 0.85. What is the ratio of the Expenses (in $) of Croatia in 2006 to that in 2012?
Provide a succinct answer. 0.62. What is the ratio of the Expenses (in $) of Lithuania in 2006 to that in 2012?
Ensure brevity in your answer.  0.28. What is the ratio of the Expenses (in $) of Macedonia in 2006 to that in 2012?
Offer a very short reply. 0.74. What is the ratio of the Expenses (in $) in Thailand in 2006 to that in 2012?
Give a very brief answer. 0.81. What is the ratio of the Expenses (in $) in Croatia in 2007 to that in 2008?
Your answer should be compact. 1.11. What is the ratio of the Expenses (in $) in Lithuania in 2007 to that in 2008?
Your response must be concise. 0.95. What is the ratio of the Expenses (in $) in Macedonia in 2007 to that in 2008?
Keep it short and to the point. 1.1. What is the ratio of the Expenses (in $) of Thailand in 2007 to that in 2008?
Make the answer very short. 1.04. What is the ratio of the Expenses (in $) in Croatia in 2007 to that in 2009?
Make the answer very short. 0.99. What is the ratio of the Expenses (in $) in Lithuania in 2007 to that in 2009?
Your response must be concise. 0.59. What is the ratio of the Expenses (in $) of Macedonia in 2007 to that in 2009?
Make the answer very short. 1.19. What is the ratio of the Expenses (in $) of Thailand in 2007 to that in 2009?
Offer a terse response. 0.96. What is the ratio of the Expenses (in $) in Croatia in 2007 to that in 2010?
Your response must be concise. 0.83. What is the ratio of the Expenses (in $) in Lithuania in 2007 to that in 2010?
Offer a terse response. 0.37. What is the ratio of the Expenses (in $) of Macedonia in 2007 to that in 2010?
Your response must be concise. 0.92. What is the ratio of the Expenses (in $) in Thailand in 2007 to that in 2010?
Keep it short and to the point. 0.74. What is the ratio of the Expenses (in $) in Croatia in 2007 to that in 2011?
Offer a terse response. 0.73. What is the ratio of the Expenses (in $) of Lithuania in 2007 to that in 2011?
Give a very brief answer. 0.33. What is the ratio of the Expenses (in $) in Macedonia in 2007 to that in 2011?
Keep it short and to the point. 0.84. What is the ratio of the Expenses (in $) of Thailand in 2007 to that in 2011?
Provide a succinct answer. 0.7. What is the ratio of the Expenses (in $) of Croatia in 2007 to that in 2012?
Provide a succinct answer. 0.63. What is the ratio of the Expenses (in $) of Lithuania in 2007 to that in 2012?
Give a very brief answer. 0.31. What is the ratio of the Expenses (in $) of Macedonia in 2007 to that in 2012?
Ensure brevity in your answer.  0.69. What is the ratio of the Expenses (in $) in Thailand in 2007 to that in 2012?
Keep it short and to the point. 0.67. What is the ratio of the Expenses (in $) in Croatia in 2008 to that in 2009?
Offer a terse response. 0.89. What is the ratio of the Expenses (in $) in Lithuania in 2008 to that in 2009?
Your answer should be very brief. 0.62. What is the ratio of the Expenses (in $) in Macedonia in 2008 to that in 2009?
Offer a terse response. 1.08. What is the ratio of the Expenses (in $) in Thailand in 2008 to that in 2009?
Provide a short and direct response. 0.92. What is the ratio of the Expenses (in $) in Croatia in 2008 to that in 2010?
Ensure brevity in your answer.  0.75. What is the ratio of the Expenses (in $) of Lithuania in 2008 to that in 2010?
Offer a very short reply. 0.39. What is the ratio of the Expenses (in $) in Macedonia in 2008 to that in 2010?
Make the answer very short. 0.83. What is the ratio of the Expenses (in $) of Thailand in 2008 to that in 2010?
Your answer should be compact. 0.71. What is the ratio of the Expenses (in $) in Croatia in 2008 to that in 2011?
Offer a very short reply. 0.66. What is the ratio of the Expenses (in $) in Lithuania in 2008 to that in 2011?
Your answer should be compact. 0.35. What is the ratio of the Expenses (in $) in Macedonia in 2008 to that in 2011?
Give a very brief answer. 0.76. What is the ratio of the Expenses (in $) in Thailand in 2008 to that in 2011?
Offer a very short reply. 0.67. What is the ratio of the Expenses (in $) in Croatia in 2008 to that in 2012?
Make the answer very short. 0.56. What is the ratio of the Expenses (in $) of Lithuania in 2008 to that in 2012?
Give a very brief answer. 0.33. What is the ratio of the Expenses (in $) of Macedonia in 2008 to that in 2012?
Provide a short and direct response. 0.63. What is the ratio of the Expenses (in $) of Thailand in 2008 to that in 2012?
Provide a succinct answer. 0.64. What is the ratio of the Expenses (in $) in Croatia in 2009 to that in 2010?
Your answer should be compact. 0.84. What is the ratio of the Expenses (in $) of Lithuania in 2009 to that in 2010?
Offer a very short reply. 0.63. What is the ratio of the Expenses (in $) in Macedonia in 2009 to that in 2010?
Offer a very short reply. 0.77. What is the ratio of the Expenses (in $) in Thailand in 2009 to that in 2010?
Ensure brevity in your answer.  0.77. What is the ratio of the Expenses (in $) of Croatia in 2009 to that in 2011?
Give a very brief answer. 0.74. What is the ratio of the Expenses (in $) of Lithuania in 2009 to that in 2011?
Make the answer very short. 0.56. What is the ratio of the Expenses (in $) in Macedonia in 2009 to that in 2011?
Provide a succinct answer. 0.7. What is the ratio of the Expenses (in $) in Thailand in 2009 to that in 2011?
Provide a short and direct response. 0.73. What is the ratio of the Expenses (in $) of Croatia in 2009 to that in 2012?
Your answer should be very brief. 0.63. What is the ratio of the Expenses (in $) in Lithuania in 2009 to that in 2012?
Offer a terse response. 0.52. What is the ratio of the Expenses (in $) in Macedonia in 2009 to that in 2012?
Provide a short and direct response. 0.58. What is the ratio of the Expenses (in $) in Thailand in 2009 to that in 2012?
Make the answer very short. 0.7. What is the ratio of the Expenses (in $) in Croatia in 2010 to that in 2011?
Your answer should be compact. 0.88. What is the ratio of the Expenses (in $) of Lithuania in 2010 to that in 2011?
Give a very brief answer. 0.89. What is the ratio of the Expenses (in $) in Macedonia in 2010 to that in 2011?
Ensure brevity in your answer.  0.91. What is the ratio of the Expenses (in $) of Thailand in 2010 to that in 2011?
Your response must be concise. 0.95. What is the ratio of the Expenses (in $) in Croatia in 2010 to that in 2012?
Offer a very short reply. 0.75. What is the ratio of the Expenses (in $) in Lithuania in 2010 to that in 2012?
Your response must be concise. 0.83. What is the ratio of the Expenses (in $) of Macedonia in 2010 to that in 2012?
Your answer should be compact. 0.75. What is the ratio of the Expenses (in $) in Thailand in 2010 to that in 2012?
Your response must be concise. 0.9. What is the ratio of the Expenses (in $) in Croatia in 2011 to that in 2012?
Offer a very short reply. 0.85. What is the ratio of the Expenses (in $) of Lithuania in 2011 to that in 2012?
Ensure brevity in your answer.  0.93. What is the ratio of the Expenses (in $) of Macedonia in 2011 to that in 2012?
Your answer should be very brief. 0.82. What is the ratio of the Expenses (in $) of Thailand in 2011 to that in 2012?
Your answer should be compact. 0.95. What is the difference between the highest and the second highest Expenses (in $) of Croatia?
Ensure brevity in your answer.  1.27e+09. What is the difference between the highest and the second highest Expenses (in $) of Lithuania?
Give a very brief answer. 1.48e+08. What is the difference between the highest and the second highest Expenses (in $) in Macedonia?
Keep it short and to the point. 7.45e+08. What is the difference between the highest and the second highest Expenses (in $) in Thailand?
Provide a short and direct response. 6.33e+09. What is the difference between the highest and the lowest Expenses (in $) of Croatia?
Ensure brevity in your answer.  3.81e+09. What is the difference between the highest and the lowest Expenses (in $) of Lithuania?
Your response must be concise. 1.56e+09. What is the difference between the highest and the lowest Expenses (in $) in Macedonia?
Keep it short and to the point. 1.77e+09. What is the difference between the highest and the lowest Expenses (in $) of Thailand?
Provide a short and direct response. 4.99e+1. 